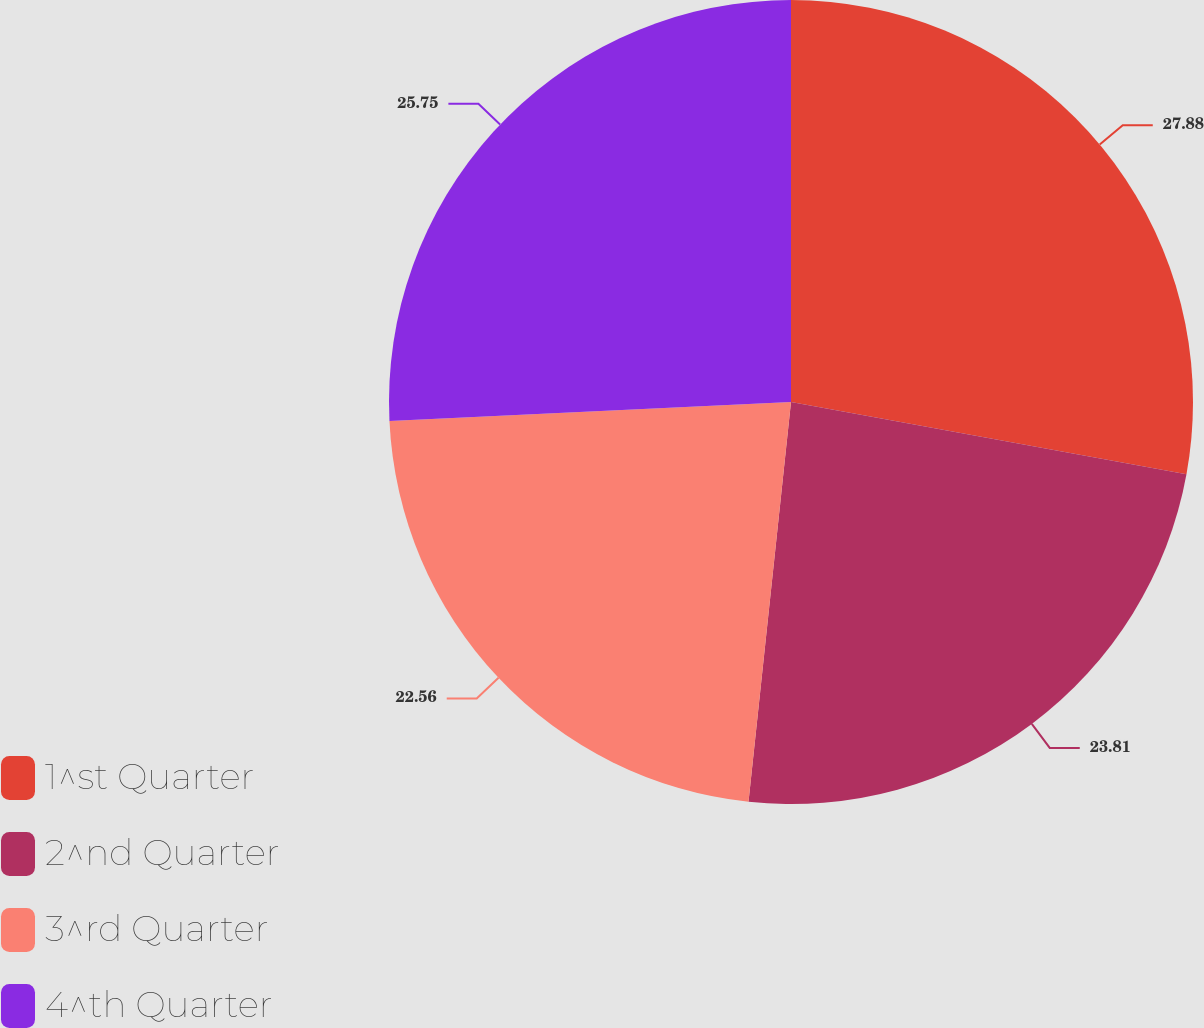<chart> <loc_0><loc_0><loc_500><loc_500><pie_chart><fcel>1^st Quarter<fcel>2^nd Quarter<fcel>3^rd Quarter<fcel>4^th Quarter<nl><fcel>27.87%<fcel>23.81%<fcel>22.56%<fcel>25.75%<nl></chart> 